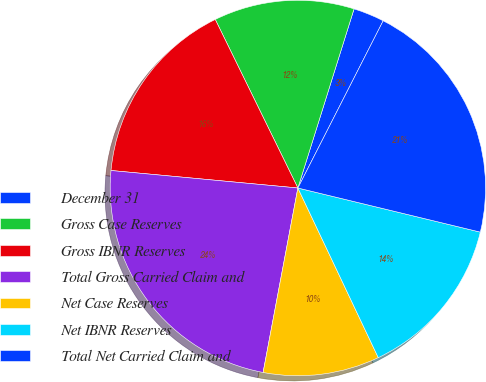Convert chart. <chart><loc_0><loc_0><loc_500><loc_500><pie_chart><fcel>December 31<fcel>Gross Case Reserves<fcel>Gross IBNR Reserves<fcel>Total Gross Carried Claim and<fcel>Net Case Reserves<fcel>Net IBNR Reserves<fcel>Total Net Carried Claim and<nl><fcel>2.67%<fcel>12.09%<fcel>16.26%<fcel>23.52%<fcel>10.01%<fcel>14.18%<fcel>21.27%<nl></chart> 